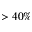Convert formula to latex. <formula><loc_0><loc_0><loc_500><loc_500>> 4 0 \%</formula> 